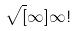<formula> <loc_0><loc_0><loc_500><loc_500>\sqrt { [ } \infty ] { \infty ! }</formula> 